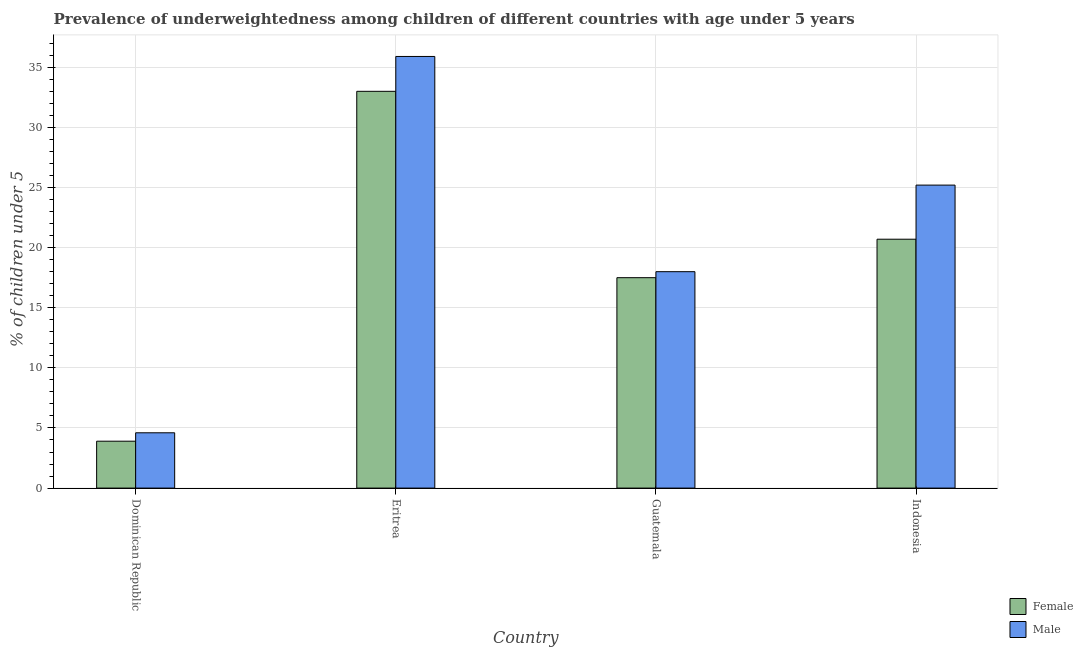Are the number of bars on each tick of the X-axis equal?
Your response must be concise. Yes. How many bars are there on the 2nd tick from the left?
Make the answer very short. 2. How many bars are there on the 1st tick from the right?
Offer a terse response. 2. What is the label of the 3rd group of bars from the left?
Offer a very short reply. Guatemala. In how many cases, is the number of bars for a given country not equal to the number of legend labels?
Offer a very short reply. 0. What is the percentage of underweighted male children in Indonesia?
Provide a succinct answer. 25.2. Across all countries, what is the maximum percentage of underweighted male children?
Offer a terse response. 35.9. Across all countries, what is the minimum percentage of underweighted female children?
Provide a succinct answer. 3.9. In which country was the percentage of underweighted female children maximum?
Your answer should be compact. Eritrea. In which country was the percentage of underweighted female children minimum?
Make the answer very short. Dominican Republic. What is the total percentage of underweighted male children in the graph?
Provide a succinct answer. 83.7. What is the difference between the percentage of underweighted male children in Eritrea and that in Indonesia?
Your answer should be compact. 10.7. What is the difference between the percentage of underweighted female children in Indonesia and the percentage of underweighted male children in Dominican Republic?
Your answer should be compact. 16.1. What is the average percentage of underweighted female children per country?
Make the answer very short. 18.78. What is the difference between the percentage of underweighted male children and percentage of underweighted female children in Indonesia?
Offer a very short reply. 4.5. What is the ratio of the percentage of underweighted female children in Dominican Republic to that in Guatemala?
Provide a short and direct response. 0.22. What is the difference between the highest and the second highest percentage of underweighted male children?
Provide a short and direct response. 10.7. What is the difference between the highest and the lowest percentage of underweighted male children?
Your response must be concise. 31.3. Is the sum of the percentage of underweighted female children in Dominican Republic and Eritrea greater than the maximum percentage of underweighted male children across all countries?
Your response must be concise. Yes. Are all the bars in the graph horizontal?
Your response must be concise. No. What is the difference between two consecutive major ticks on the Y-axis?
Give a very brief answer. 5. Does the graph contain any zero values?
Make the answer very short. No. Where does the legend appear in the graph?
Offer a terse response. Bottom right. How many legend labels are there?
Provide a short and direct response. 2. What is the title of the graph?
Give a very brief answer. Prevalence of underweightedness among children of different countries with age under 5 years. Does "Goods" appear as one of the legend labels in the graph?
Give a very brief answer. No. What is the label or title of the X-axis?
Ensure brevity in your answer.  Country. What is the label or title of the Y-axis?
Make the answer very short.  % of children under 5. What is the  % of children under 5 in Female in Dominican Republic?
Give a very brief answer. 3.9. What is the  % of children under 5 in Male in Dominican Republic?
Your answer should be very brief. 4.6. What is the  % of children under 5 of Female in Eritrea?
Make the answer very short. 33. What is the  % of children under 5 of Male in Eritrea?
Provide a short and direct response. 35.9. What is the  % of children under 5 of Female in Guatemala?
Make the answer very short. 17.5. What is the  % of children under 5 of Female in Indonesia?
Offer a very short reply. 20.7. What is the  % of children under 5 in Male in Indonesia?
Make the answer very short. 25.2. Across all countries, what is the maximum  % of children under 5 in Male?
Your response must be concise. 35.9. Across all countries, what is the minimum  % of children under 5 of Female?
Your response must be concise. 3.9. Across all countries, what is the minimum  % of children under 5 in Male?
Keep it short and to the point. 4.6. What is the total  % of children under 5 of Female in the graph?
Ensure brevity in your answer.  75.1. What is the total  % of children under 5 in Male in the graph?
Offer a very short reply. 83.7. What is the difference between the  % of children under 5 in Female in Dominican Republic and that in Eritrea?
Make the answer very short. -29.1. What is the difference between the  % of children under 5 of Male in Dominican Republic and that in Eritrea?
Make the answer very short. -31.3. What is the difference between the  % of children under 5 of Female in Dominican Republic and that in Guatemala?
Offer a terse response. -13.6. What is the difference between the  % of children under 5 of Male in Dominican Republic and that in Guatemala?
Keep it short and to the point. -13.4. What is the difference between the  % of children under 5 of Female in Dominican Republic and that in Indonesia?
Provide a short and direct response. -16.8. What is the difference between the  % of children under 5 in Male in Dominican Republic and that in Indonesia?
Ensure brevity in your answer.  -20.6. What is the difference between the  % of children under 5 in Female in Eritrea and that in Guatemala?
Your response must be concise. 15.5. What is the difference between the  % of children under 5 in Male in Eritrea and that in Guatemala?
Your response must be concise. 17.9. What is the difference between the  % of children under 5 of Male in Eritrea and that in Indonesia?
Give a very brief answer. 10.7. What is the difference between the  % of children under 5 of Female in Dominican Republic and the  % of children under 5 of Male in Eritrea?
Ensure brevity in your answer.  -32. What is the difference between the  % of children under 5 of Female in Dominican Republic and the  % of children under 5 of Male in Guatemala?
Provide a short and direct response. -14.1. What is the difference between the  % of children under 5 of Female in Dominican Republic and the  % of children under 5 of Male in Indonesia?
Offer a terse response. -21.3. What is the difference between the  % of children under 5 of Female in Eritrea and the  % of children under 5 of Male in Guatemala?
Your answer should be compact. 15. What is the difference between the  % of children under 5 in Female in Guatemala and the  % of children under 5 in Male in Indonesia?
Offer a very short reply. -7.7. What is the average  % of children under 5 of Female per country?
Keep it short and to the point. 18.77. What is the average  % of children under 5 of Male per country?
Your answer should be compact. 20.93. What is the ratio of the  % of children under 5 in Female in Dominican Republic to that in Eritrea?
Make the answer very short. 0.12. What is the ratio of the  % of children under 5 in Male in Dominican Republic to that in Eritrea?
Your answer should be very brief. 0.13. What is the ratio of the  % of children under 5 of Female in Dominican Republic to that in Guatemala?
Make the answer very short. 0.22. What is the ratio of the  % of children under 5 in Male in Dominican Republic to that in Guatemala?
Keep it short and to the point. 0.26. What is the ratio of the  % of children under 5 of Female in Dominican Republic to that in Indonesia?
Offer a very short reply. 0.19. What is the ratio of the  % of children under 5 of Male in Dominican Republic to that in Indonesia?
Your answer should be very brief. 0.18. What is the ratio of the  % of children under 5 of Female in Eritrea to that in Guatemala?
Your answer should be very brief. 1.89. What is the ratio of the  % of children under 5 of Male in Eritrea to that in Guatemala?
Ensure brevity in your answer.  1.99. What is the ratio of the  % of children under 5 in Female in Eritrea to that in Indonesia?
Offer a very short reply. 1.59. What is the ratio of the  % of children under 5 in Male in Eritrea to that in Indonesia?
Provide a short and direct response. 1.42. What is the ratio of the  % of children under 5 in Female in Guatemala to that in Indonesia?
Your answer should be very brief. 0.85. What is the ratio of the  % of children under 5 in Male in Guatemala to that in Indonesia?
Give a very brief answer. 0.71. What is the difference between the highest and the second highest  % of children under 5 of Female?
Your answer should be compact. 12.3. What is the difference between the highest and the second highest  % of children under 5 of Male?
Provide a succinct answer. 10.7. What is the difference between the highest and the lowest  % of children under 5 in Female?
Provide a short and direct response. 29.1. What is the difference between the highest and the lowest  % of children under 5 in Male?
Make the answer very short. 31.3. 